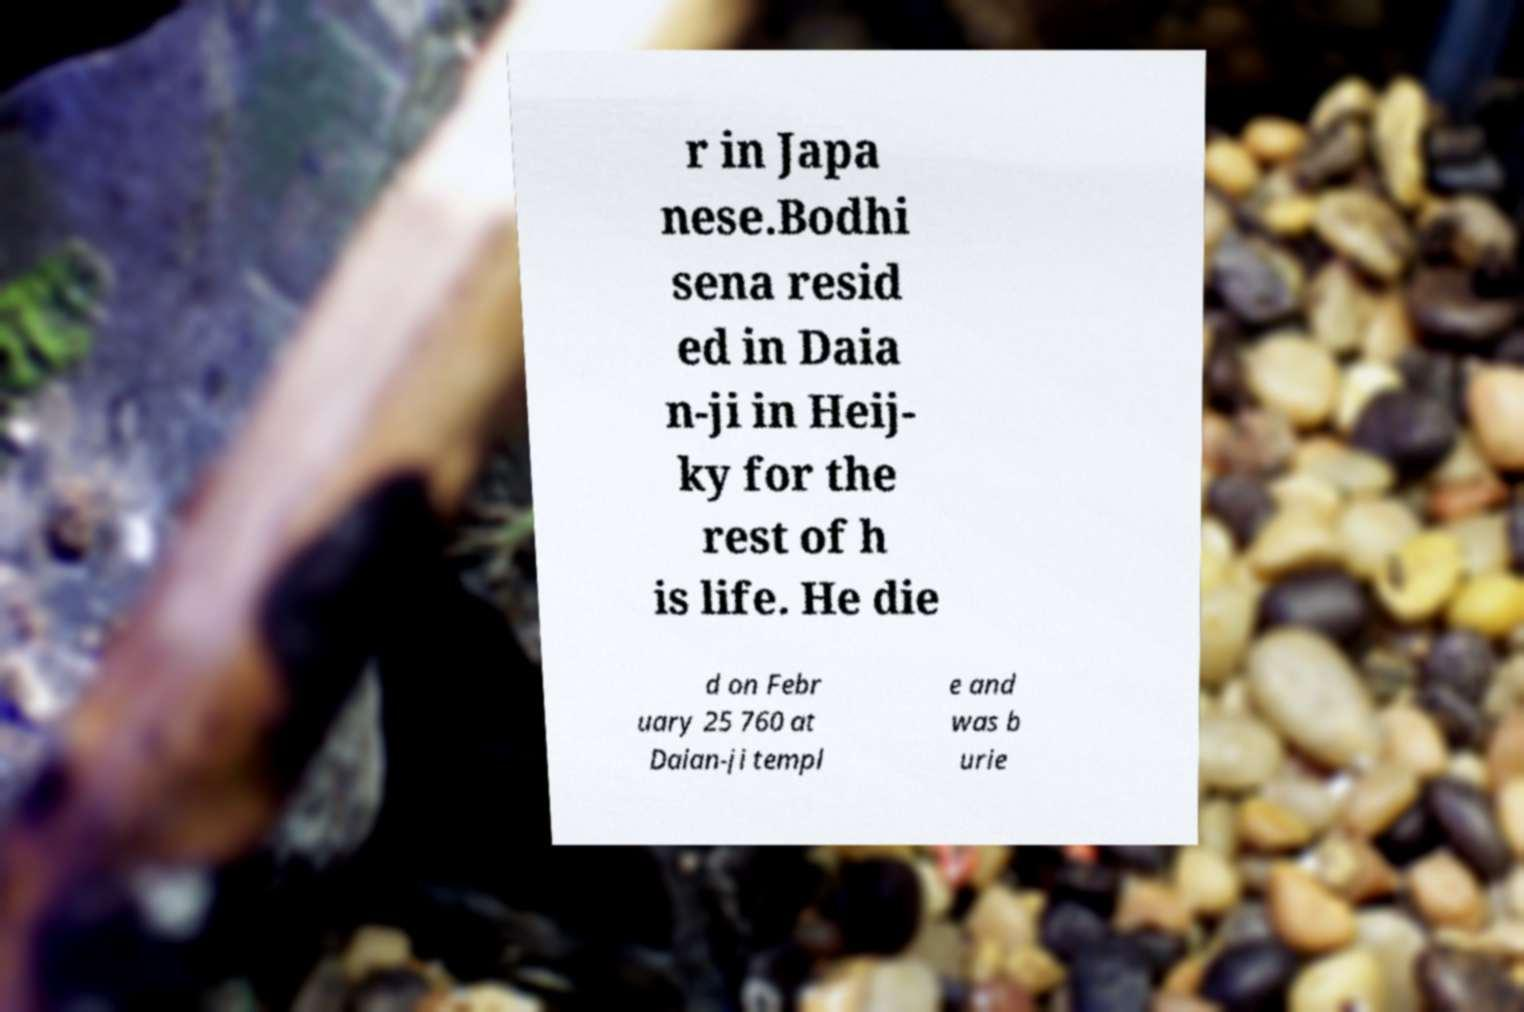Can you read and provide the text displayed in the image?This photo seems to have some interesting text. Can you extract and type it out for me? r in Japa nese.Bodhi sena resid ed in Daia n-ji in Heij- ky for the rest of h is life. He die d on Febr uary 25 760 at Daian-ji templ e and was b urie 